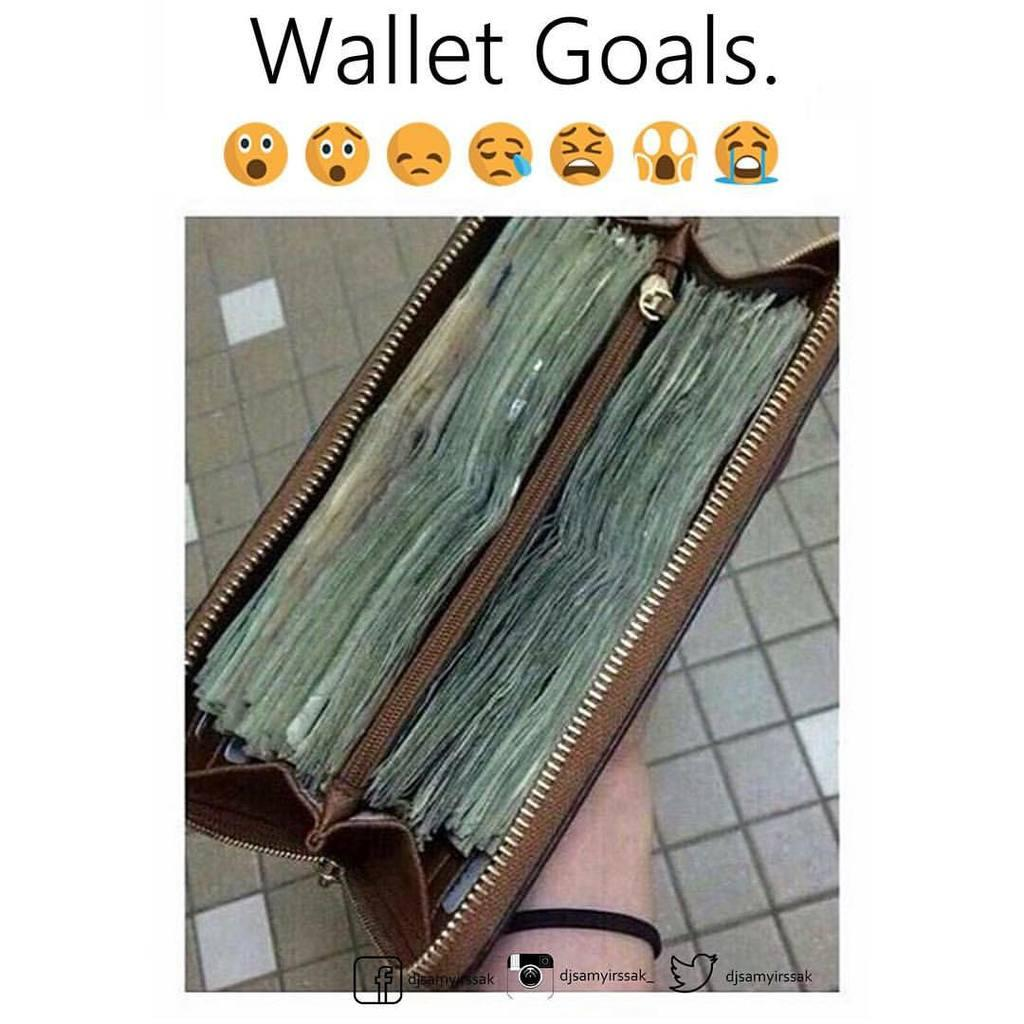What object can be seen in the image? There is a wallet in the image. What type of flooring is visible in the image? The floor in the image consists of tiles. What is present at the top and bottom of the image? There is text at the top and bottom of the image. What type of wire is holding the building together in the image? There is no building or wire present in the image. What kind of test is being conducted in the image? There is no test being conducted in the image. 